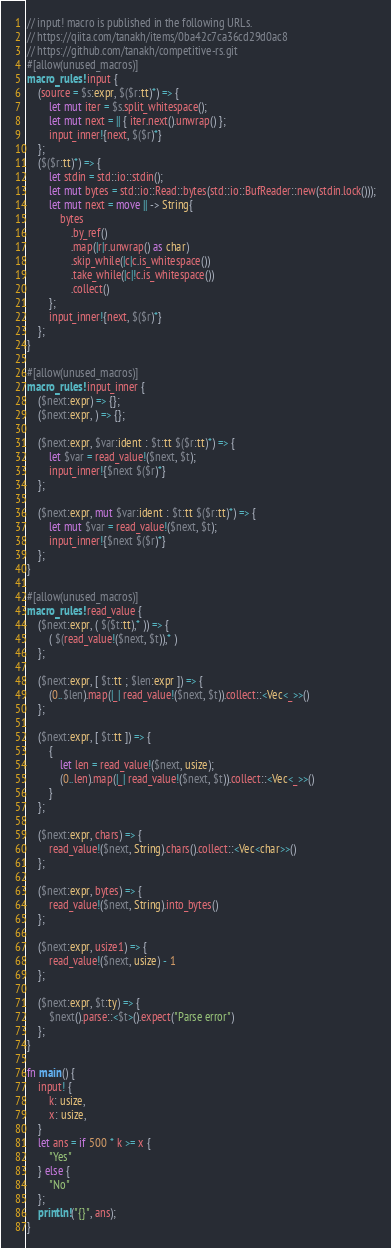<code> <loc_0><loc_0><loc_500><loc_500><_Rust_>// input! macro is published in the following URLs.
// https://qiita.com/tanakh/items/0ba42c7ca36cd29d0ac8
// https://github.com/tanakh/competitive-rs.git
#[allow(unused_macros)]
macro_rules! input {
    (source = $s:expr, $($r:tt)*) => {
        let mut iter = $s.split_whitespace();
        let mut next = || { iter.next().unwrap() };
        input_inner!{next, $($r)*}
    };
    ($($r:tt)*) => {
        let stdin = std::io::stdin();
        let mut bytes = std::io::Read::bytes(std::io::BufReader::new(stdin.lock()));
        let mut next = move || -> String{
            bytes
                .by_ref()
                .map(|r|r.unwrap() as char)
                .skip_while(|c|c.is_whitespace())
                .take_while(|c|!c.is_whitespace())
                .collect()
        };
        input_inner!{next, $($r)*}
    };
}

#[allow(unused_macros)]
macro_rules! input_inner {
    ($next:expr) => {};
    ($next:expr, ) => {};

    ($next:expr, $var:ident : $t:tt $($r:tt)*) => {
        let $var = read_value!($next, $t);
        input_inner!{$next $($r)*}
    };

    ($next:expr, mut $var:ident : $t:tt $($r:tt)*) => {
        let mut $var = read_value!($next, $t);
        input_inner!{$next $($r)*}
    };
}

#[allow(unused_macros)]
macro_rules! read_value {
    ($next:expr, ( $($t:tt),* )) => {
        ( $(read_value!($next, $t)),* )
    };

    ($next:expr, [ $t:tt ; $len:expr ]) => {
        (0..$len).map(|_| read_value!($next, $t)).collect::<Vec<_>>()
    };

    ($next:expr, [ $t:tt ]) => {
        {
            let len = read_value!($next, usize);
            (0..len).map(|_| read_value!($next, $t)).collect::<Vec<_>>()
        }
    };

    ($next:expr, chars) => {
        read_value!($next, String).chars().collect::<Vec<char>>()
    };

    ($next:expr, bytes) => {
        read_value!($next, String).into_bytes()
    };

    ($next:expr, usize1) => {
        read_value!($next, usize) - 1
    };

    ($next:expr, $t:ty) => {
        $next().parse::<$t>().expect("Parse error")
    };
}

fn main() {
    input! {
        k: usize,
        x: usize,
    }
    let ans = if 500 * k >= x {
        "Yes"
    } else {
        "No"
    };
    println!("{}", ans);
}
</code> 